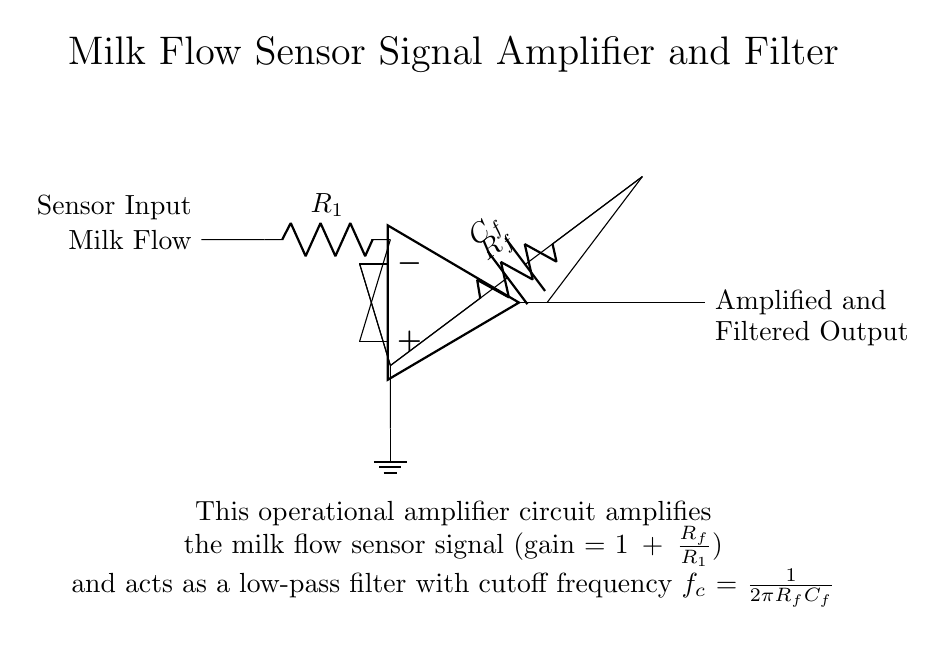What is the type of the main active component in this circuit? The main active component in the circuit is the operational amplifier, which is indicated by the op amp symbol. Operational amplifiers are used for signal amplification and processing in various circuits.
Answer: Operational amplifier What does the resistor R_f do in this circuit? The resistor R_f acts as a feedback resistor that determines the gain of the operational amplifier. The gain is calculated using the formula \(1 + \frac{R_f}{R_1}\), where R_1 is the input resistor.
Answer: Feedback gain What is the purpose of the capacitor C_f in this circuit? The capacitor C_f serves to filter the output signal, creating a low-pass filter effect. It works with the resistor R_f to define the cutoff frequency, which is calculated by \(f_c = \frac{1}{2\pi R_f C_f}\).
Answer: Low-pass filter What is the gain of the amplifier if R_f is 10k ohm and R_1 is 1k ohm? The gain can be calculated using the formula \(1 + \frac{R_f}{R_1}\). Plugging in the values, we have \(1 + \frac{10k}{1k} = 11\). Therefore, the gain is 11.
Answer: 11 What is the maximum frequency at which the output signal remains effective? The maximum effective frequency is determined by the cutoff frequency \(f_c\), which is given by the formula; substituting values into \(f_c = \frac{1}{2\pi R_f C_f}\) allows for determination once R_f and C_f are known. The specifics depend on those component values.
Answer: Depends on values 